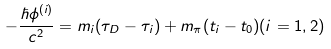<formula> <loc_0><loc_0><loc_500><loc_500>- \frac { \hbar { \phi } ^ { ( i ) } } { c ^ { 2 } } = m _ { i } ( \tau _ { D } - \tau _ { i } ) + m _ { \pi } ( t _ { i } - t _ { 0 } ) ( i = 1 , 2 )</formula> 